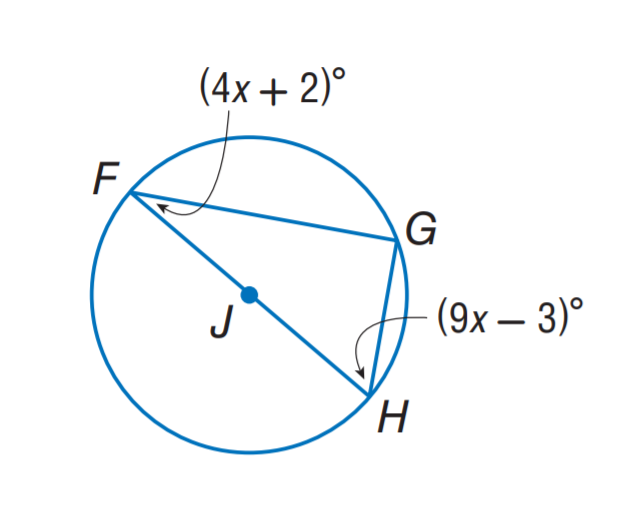Answer the mathemtical geometry problem and directly provide the correct option letter.
Question: Find m \angle F.
Choices: A: 20 B: 30 C: 40 D: 60 B 